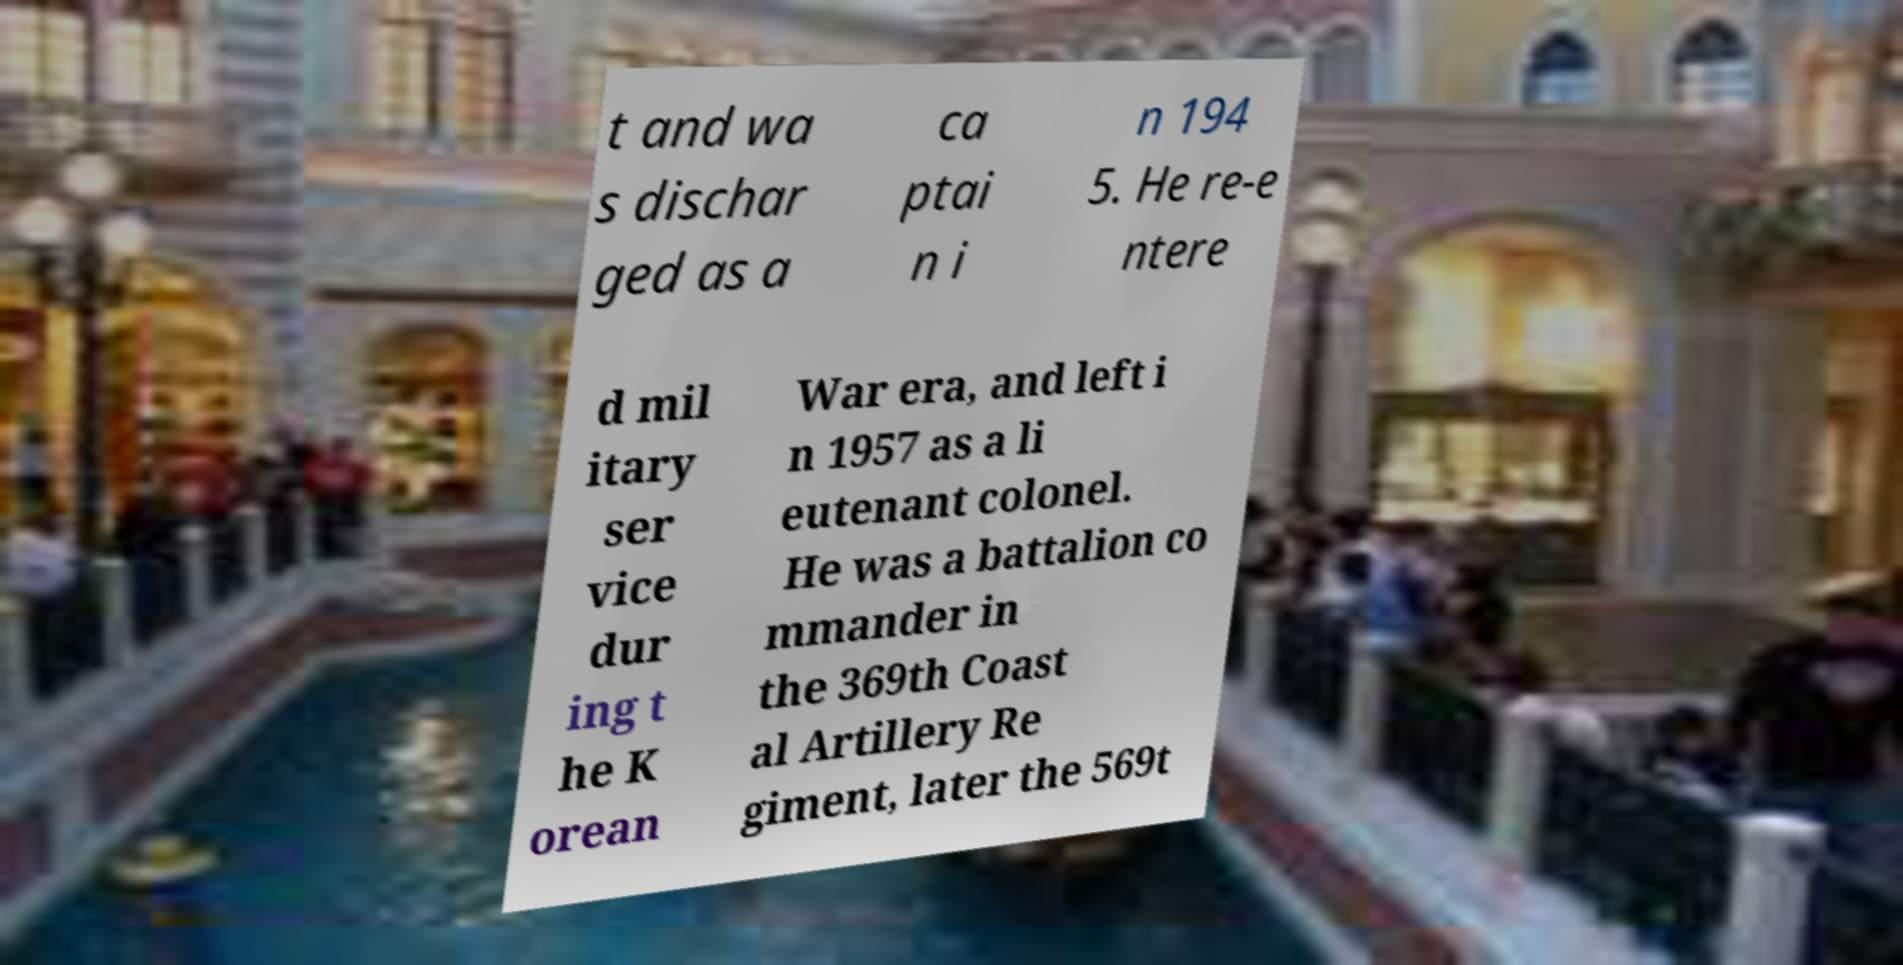Can you read and provide the text displayed in the image?This photo seems to have some interesting text. Can you extract and type it out for me? t and wa s dischar ged as a ca ptai n i n 194 5. He re-e ntere d mil itary ser vice dur ing t he K orean War era, and left i n 1957 as a li eutenant colonel. He was a battalion co mmander in the 369th Coast al Artillery Re giment, later the 569t 